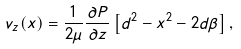<formula> <loc_0><loc_0><loc_500><loc_500>v _ { z } ( x ) = \frac { 1 } { 2 \mu } \frac { \partial P } { \partial z } \left [ d ^ { 2 } - x ^ { 2 } - 2 d \beta \right ] ,</formula> 